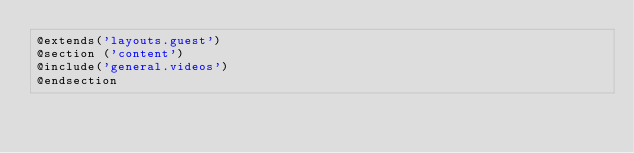Convert code to text. <code><loc_0><loc_0><loc_500><loc_500><_PHP_>@extends('layouts.guest')
@section ('content')
@include('general.videos')
@endsection</code> 